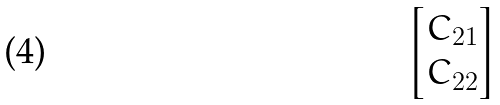<formula> <loc_0><loc_0><loc_500><loc_500>\begin{bmatrix} C _ { 2 1 } \\ C _ { 2 2 } \end{bmatrix}</formula> 